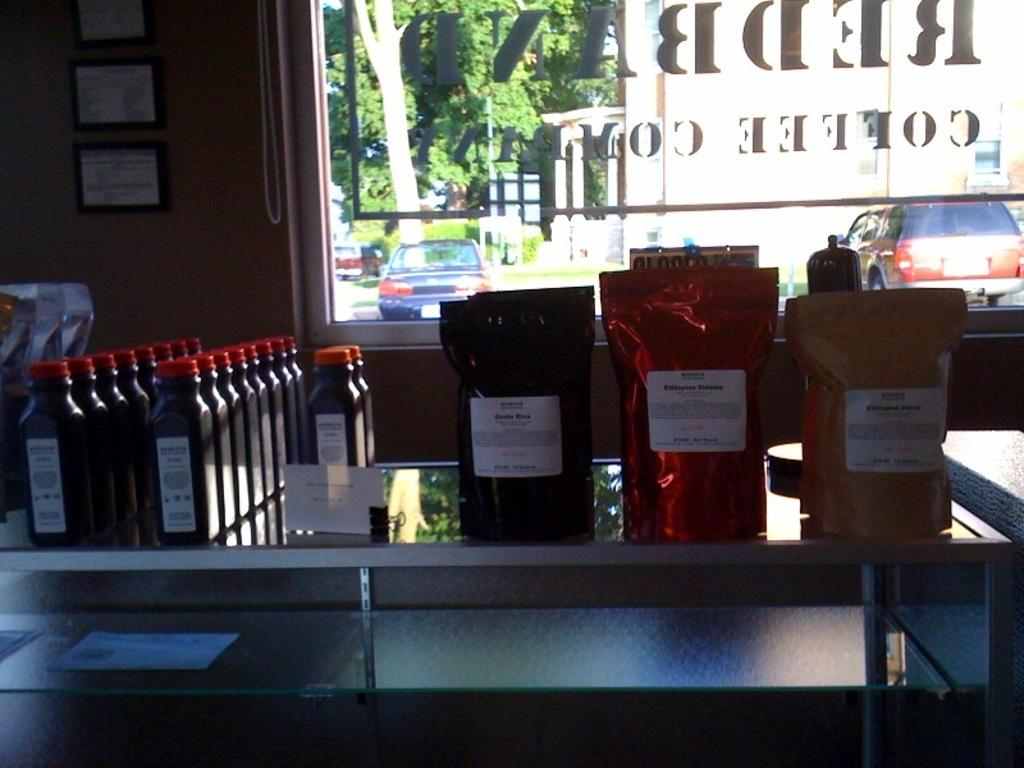What type of space is shown in the image? The image depicts a room. What objects can be seen on the table in the room? There are bottles and food items on the table in the room. What feature allows natural light and a view of the outdoors into the room? There is a window in the room. What can be seen through the window? Trees and vehicles are visible through the window. What type of bone is visible in the image? There is no bone present in the image. Can you describe the bite marks on the bone in the image? There is no bone or bite marks present in the image. 